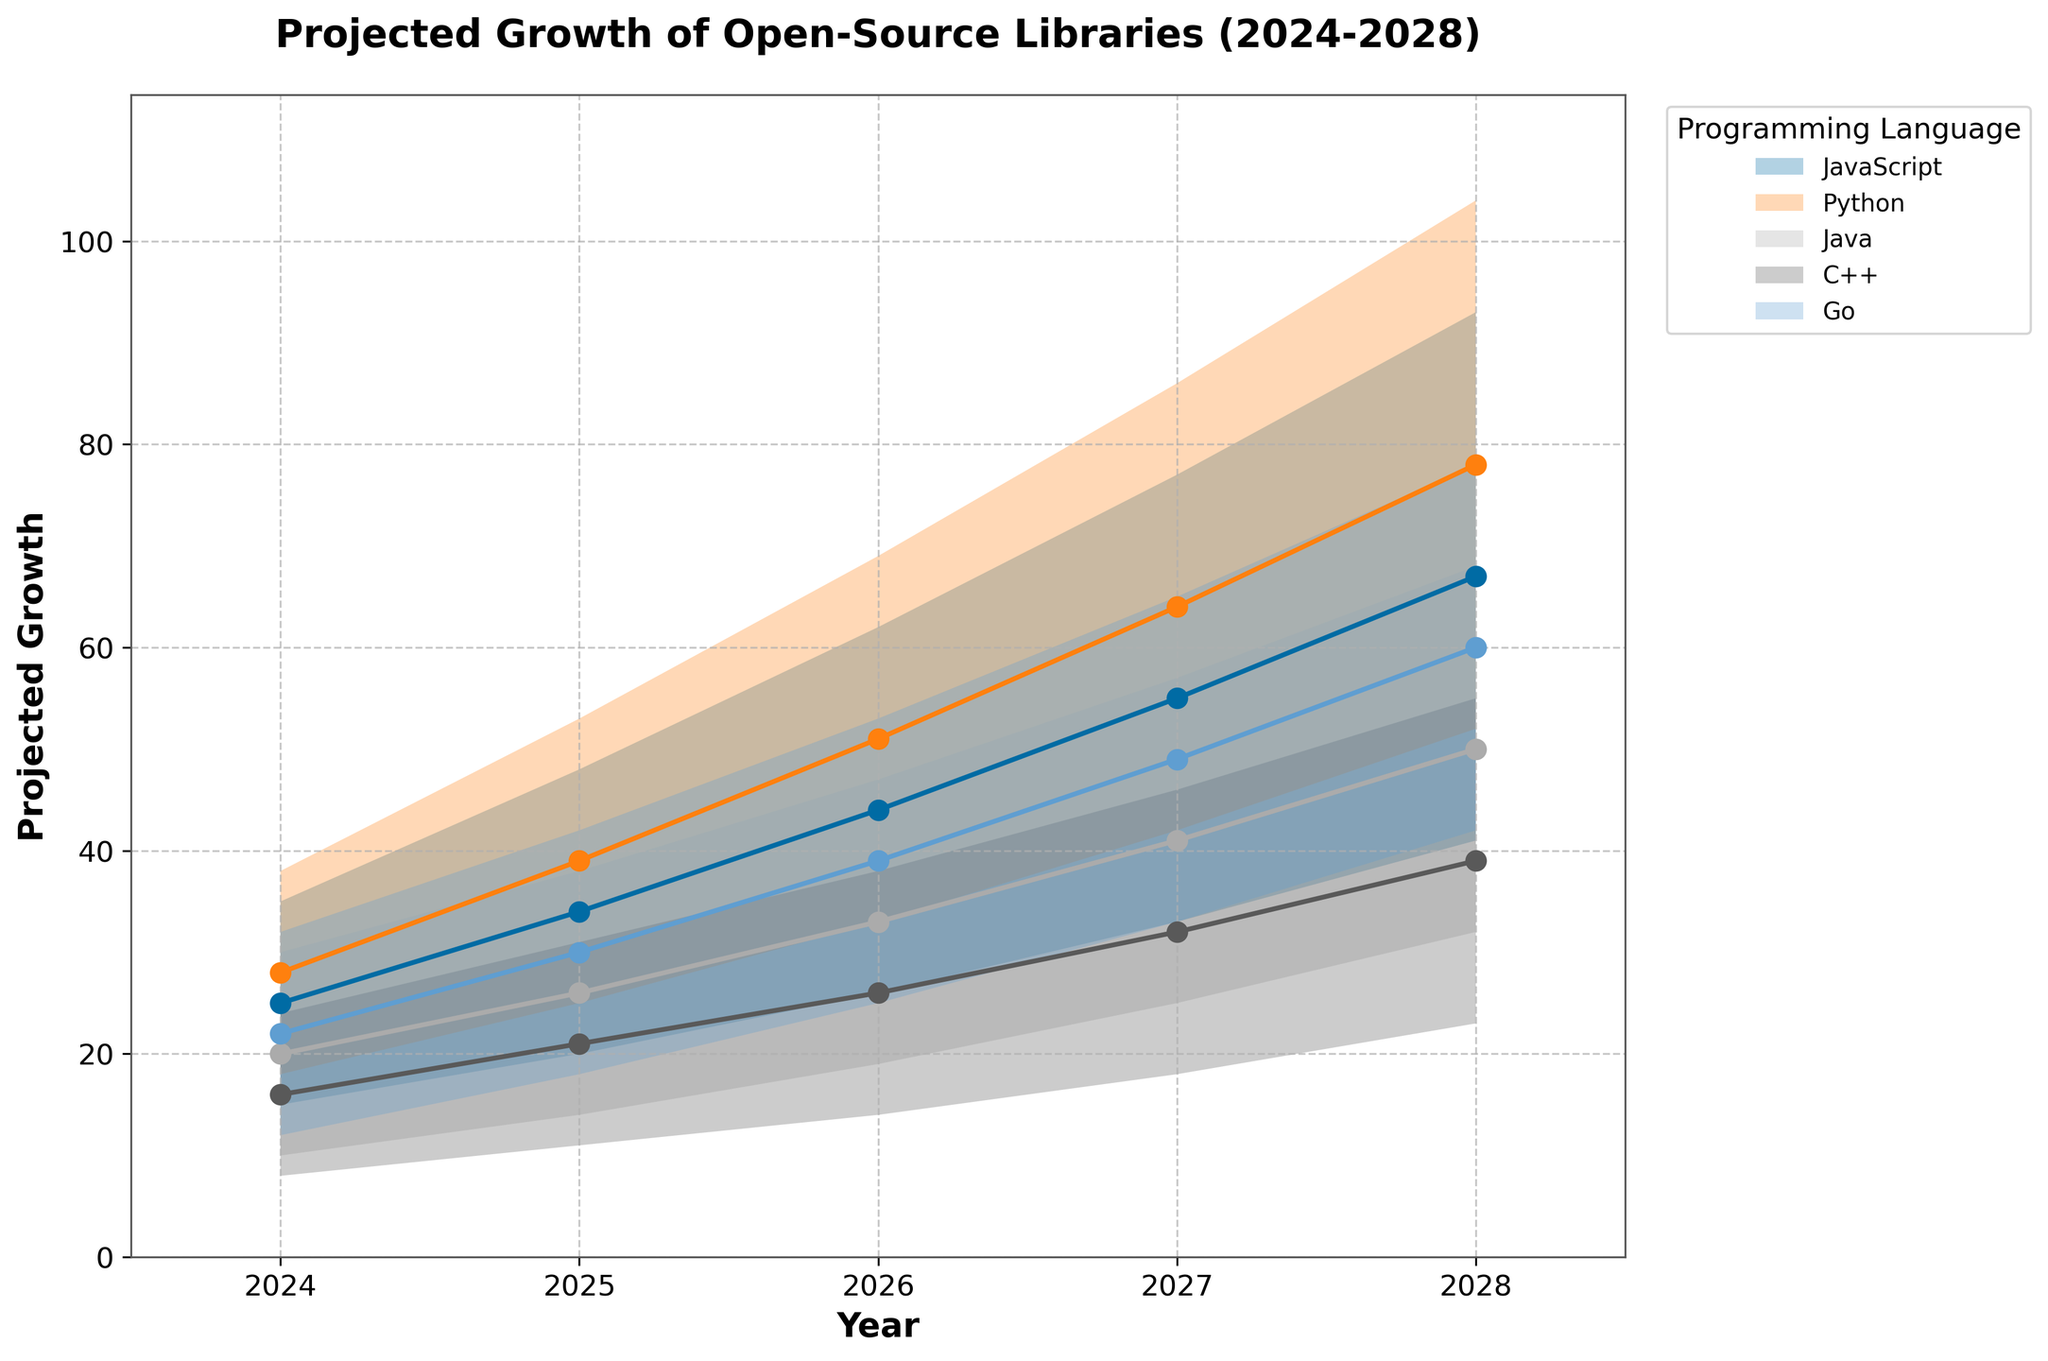What is the projected growth range for JavaScript libraries in 2028? From the plot, we can directly see the shaded region for JavaScript in 2028 marked from the lowest to the highest projections.
Answer: 41 to 93 Which programming language shows the highest median growth in 2026? Look at the points marked in the middle of the shaded regions for all languages in 2026. The highlighted median value for Python is the highest.
Answer: Python By how much is the minimum projected growth of Go in 2027 higher than in 2025? Check the lower boundary of the shaded area for Go in 2027 and 2025 and subtract the latter from the former (33 - 18).
Answer: 15 What is the overall trend in projected growth for open-source libraries from 2024 to 2028? Observe how the shaded areas expand for each language over the years from 2024 to 2028. The projections show a growing trend in all programming languages.
Answer: Growing trend Which programming language exhibits the smallest growth projection interval in 2025? Compare the widths of the shaded regions in 2025 for each language, focusing on the range from low to high projections. C++ shows the smallest interval (11 to 31, a range of 20).
Answer: C++ How does the projected growth of Python in 2028 compare to JavaScript and Go in the same year? Look at the mid-values for Python, JavaScript, and Go in 2028. Python has the highest median value (78) compared to JavaScript (67) and Go (60).
Answer: Higher What is the difference in the highest projected growth between Python and Java in 2027? Check the highest projections for Python and Java in 2027 (86 for Python and 57 for Java) and subtract the latter from the former.
Answer: 29 What is the projected median value for C++ in 2026? Locate the middle point in the shaded region for C++ in 2026, marked as “Mid” value in the data.
Answer: 26 Examine the uncertainty in the growth projections for Java and assess how it changes from 2024 to 2028. Evaluate the width of Java's projection intervals from 2024 to 2028. The range increases from 20 (10 to 30) in 2024 to 36 (32 to 68) in 2028, showing increasing uncertainty.
Answer: Increasing uncertainty Which language shows the highest projected growth in any single year, and what is that value? Identify the highest point in the entire chart, which belongs to Python in 2028.
Answer: Python, 104 